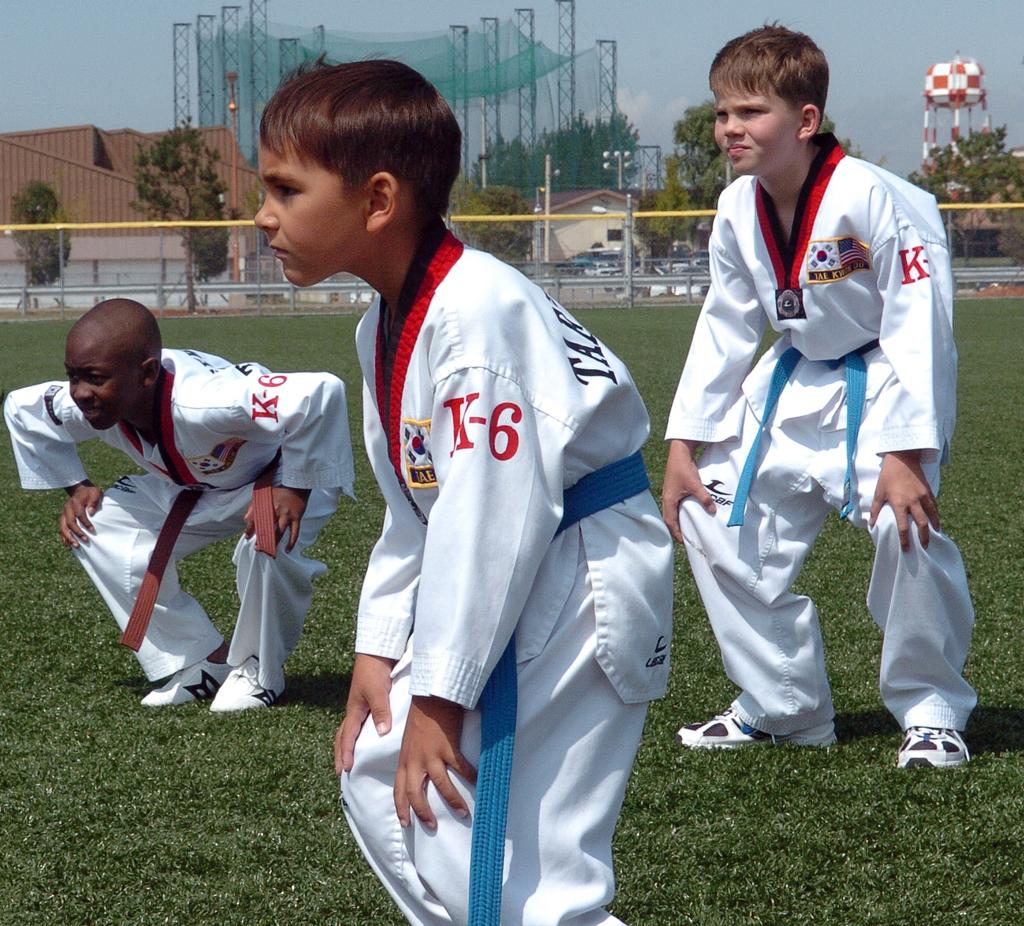Provide a one-sentence caption for the provided image. Three young boys in a field are wearing karate uniforms that say K-6. 